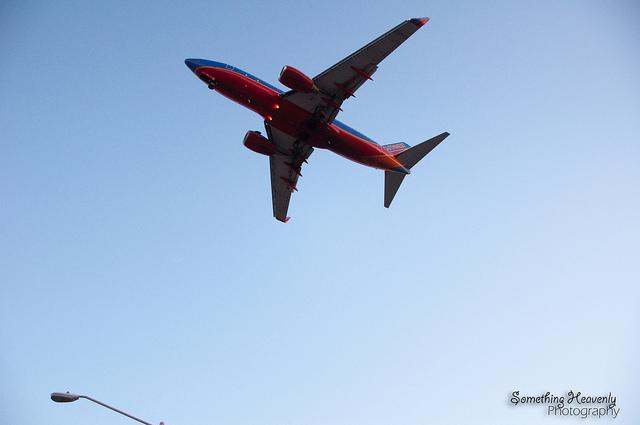How many airplane doors are visible?
Concise answer only. 0. How many different colors is this airplane?
Answer briefly. 3. Is there a street light?
Quick response, please. Yes. What color is the bottom of the airplane?
Write a very short answer. Red. 